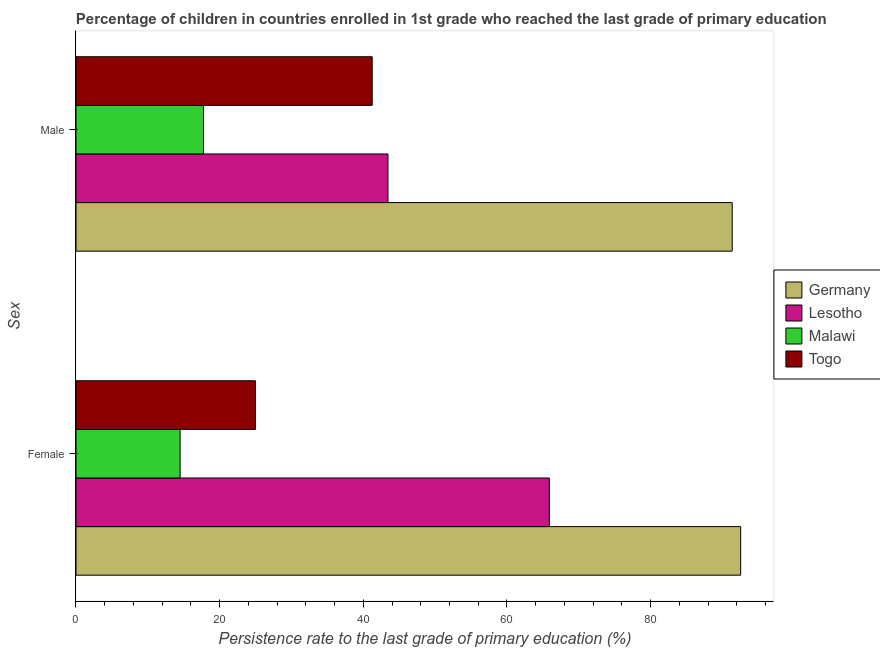How many different coloured bars are there?
Offer a very short reply. 4. How many bars are there on the 2nd tick from the bottom?
Your answer should be compact. 4. What is the persistence rate of male students in Togo?
Your response must be concise. 41.24. Across all countries, what is the maximum persistence rate of male students?
Your answer should be compact. 91.37. Across all countries, what is the minimum persistence rate of female students?
Your answer should be compact. 14.5. In which country was the persistence rate of female students minimum?
Provide a short and direct response. Malawi. What is the total persistence rate of female students in the graph?
Offer a very short reply. 197.93. What is the difference between the persistence rate of male students in Germany and that in Togo?
Keep it short and to the point. 50.13. What is the difference between the persistence rate of female students in Germany and the persistence rate of male students in Togo?
Provide a succinct answer. 51.3. What is the average persistence rate of female students per country?
Your response must be concise. 49.48. What is the difference between the persistence rate of female students and persistence rate of male students in Togo?
Keep it short and to the point. -16.26. What is the ratio of the persistence rate of male students in Malawi to that in Germany?
Ensure brevity in your answer.  0.19. Is the persistence rate of male students in Germany less than that in Lesotho?
Offer a terse response. No. What does the 2nd bar from the top in Female represents?
Your response must be concise. Malawi. Are all the bars in the graph horizontal?
Provide a succinct answer. Yes. What is the difference between two consecutive major ticks on the X-axis?
Ensure brevity in your answer.  20. Are the values on the major ticks of X-axis written in scientific E-notation?
Offer a very short reply. No. Does the graph contain any zero values?
Keep it short and to the point. No. Does the graph contain grids?
Make the answer very short. No. How many legend labels are there?
Make the answer very short. 4. How are the legend labels stacked?
Keep it short and to the point. Vertical. What is the title of the graph?
Your answer should be compact. Percentage of children in countries enrolled in 1st grade who reached the last grade of primary education. What is the label or title of the X-axis?
Offer a terse response. Persistence rate to the last grade of primary education (%). What is the label or title of the Y-axis?
Offer a terse response. Sex. What is the Persistence rate to the last grade of primary education (%) of Germany in Female?
Make the answer very short. 92.54. What is the Persistence rate to the last grade of primary education (%) of Lesotho in Female?
Offer a very short reply. 65.9. What is the Persistence rate to the last grade of primary education (%) of Malawi in Female?
Provide a short and direct response. 14.5. What is the Persistence rate to the last grade of primary education (%) in Togo in Female?
Your response must be concise. 24.99. What is the Persistence rate to the last grade of primary education (%) of Germany in Male?
Your answer should be compact. 91.37. What is the Persistence rate to the last grade of primary education (%) of Lesotho in Male?
Ensure brevity in your answer.  43.44. What is the Persistence rate to the last grade of primary education (%) of Malawi in Male?
Your answer should be compact. 17.75. What is the Persistence rate to the last grade of primary education (%) of Togo in Male?
Ensure brevity in your answer.  41.24. Across all Sex, what is the maximum Persistence rate to the last grade of primary education (%) in Germany?
Your answer should be compact. 92.54. Across all Sex, what is the maximum Persistence rate to the last grade of primary education (%) in Lesotho?
Your answer should be compact. 65.9. Across all Sex, what is the maximum Persistence rate to the last grade of primary education (%) in Malawi?
Your answer should be compact. 17.75. Across all Sex, what is the maximum Persistence rate to the last grade of primary education (%) of Togo?
Offer a terse response. 41.24. Across all Sex, what is the minimum Persistence rate to the last grade of primary education (%) of Germany?
Provide a short and direct response. 91.37. Across all Sex, what is the minimum Persistence rate to the last grade of primary education (%) in Lesotho?
Offer a terse response. 43.44. Across all Sex, what is the minimum Persistence rate to the last grade of primary education (%) in Malawi?
Offer a terse response. 14.5. Across all Sex, what is the minimum Persistence rate to the last grade of primary education (%) in Togo?
Provide a succinct answer. 24.99. What is the total Persistence rate to the last grade of primary education (%) of Germany in the graph?
Your answer should be compact. 183.92. What is the total Persistence rate to the last grade of primary education (%) of Lesotho in the graph?
Your answer should be very brief. 109.34. What is the total Persistence rate to the last grade of primary education (%) in Malawi in the graph?
Offer a terse response. 32.25. What is the total Persistence rate to the last grade of primary education (%) of Togo in the graph?
Provide a succinct answer. 66.23. What is the difference between the Persistence rate to the last grade of primary education (%) of Germany in Female and that in Male?
Keep it short and to the point. 1.17. What is the difference between the Persistence rate to the last grade of primary education (%) of Lesotho in Female and that in Male?
Make the answer very short. 22.47. What is the difference between the Persistence rate to the last grade of primary education (%) of Malawi in Female and that in Male?
Your response must be concise. -3.25. What is the difference between the Persistence rate to the last grade of primary education (%) in Togo in Female and that in Male?
Your answer should be compact. -16.26. What is the difference between the Persistence rate to the last grade of primary education (%) in Germany in Female and the Persistence rate to the last grade of primary education (%) in Lesotho in Male?
Make the answer very short. 49.11. What is the difference between the Persistence rate to the last grade of primary education (%) of Germany in Female and the Persistence rate to the last grade of primary education (%) of Malawi in Male?
Make the answer very short. 74.79. What is the difference between the Persistence rate to the last grade of primary education (%) in Germany in Female and the Persistence rate to the last grade of primary education (%) in Togo in Male?
Make the answer very short. 51.3. What is the difference between the Persistence rate to the last grade of primary education (%) in Lesotho in Female and the Persistence rate to the last grade of primary education (%) in Malawi in Male?
Your response must be concise. 48.15. What is the difference between the Persistence rate to the last grade of primary education (%) of Lesotho in Female and the Persistence rate to the last grade of primary education (%) of Togo in Male?
Your answer should be compact. 24.66. What is the difference between the Persistence rate to the last grade of primary education (%) in Malawi in Female and the Persistence rate to the last grade of primary education (%) in Togo in Male?
Your response must be concise. -26.74. What is the average Persistence rate to the last grade of primary education (%) of Germany per Sex?
Offer a terse response. 91.96. What is the average Persistence rate to the last grade of primary education (%) of Lesotho per Sex?
Your answer should be compact. 54.67. What is the average Persistence rate to the last grade of primary education (%) of Malawi per Sex?
Provide a succinct answer. 16.13. What is the average Persistence rate to the last grade of primary education (%) in Togo per Sex?
Your answer should be very brief. 33.11. What is the difference between the Persistence rate to the last grade of primary education (%) in Germany and Persistence rate to the last grade of primary education (%) in Lesotho in Female?
Make the answer very short. 26.64. What is the difference between the Persistence rate to the last grade of primary education (%) in Germany and Persistence rate to the last grade of primary education (%) in Malawi in Female?
Your answer should be compact. 78.04. What is the difference between the Persistence rate to the last grade of primary education (%) of Germany and Persistence rate to the last grade of primary education (%) of Togo in Female?
Offer a very short reply. 67.56. What is the difference between the Persistence rate to the last grade of primary education (%) in Lesotho and Persistence rate to the last grade of primary education (%) in Malawi in Female?
Provide a short and direct response. 51.4. What is the difference between the Persistence rate to the last grade of primary education (%) of Lesotho and Persistence rate to the last grade of primary education (%) of Togo in Female?
Your answer should be very brief. 40.92. What is the difference between the Persistence rate to the last grade of primary education (%) of Malawi and Persistence rate to the last grade of primary education (%) of Togo in Female?
Offer a terse response. -10.49. What is the difference between the Persistence rate to the last grade of primary education (%) in Germany and Persistence rate to the last grade of primary education (%) in Lesotho in Male?
Offer a very short reply. 47.93. What is the difference between the Persistence rate to the last grade of primary education (%) of Germany and Persistence rate to the last grade of primary education (%) of Malawi in Male?
Offer a very short reply. 73.62. What is the difference between the Persistence rate to the last grade of primary education (%) in Germany and Persistence rate to the last grade of primary education (%) in Togo in Male?
Provide a short and direct response. 50.13. What is the difference between the Persistence rate to the last grade of primary education (%) of Lesotho and Persistence rate to the last grade of primary education (%) of Malawi in Male?
Ensure brevity in your answer.  25.68. What is the difference between the Persistence rate to the last grade of primary education (%) of Lesotho and Persistence rate to the last grade of primary education (%) of Togo in Male?
Offer a terse response. 2.19. What is the difference between the Persistence rate to the last grade of primary education (%) of Malawi and Persistence rate to the last grade of primary education (%) of Togo in Male?
Provide a short and direct response. -23.49. What is the ratio of the Persistence rate to the last grade of primary education (%) of Germany in Female to that in Male?
Offer a very short reply. 1.01. What is the ratio of the Persistence rate to the last grade of primary education (%) of Lesotho in Female to that in Male?
Your answer should be very brief. 1.52. What is the ratio of the Persistence rate to the last grade of primary education (%) of Malawi in Female to that in Male?
Ensure brevity in your answer.  0.82. What is the ratio of the Persistence rate to the last grade of primary education (%) in Togo in Female to that in Male?
Make the answer very short. 0.61. What is the difference between the highest and the second highest Persistence rate to the last grade of primary education (%) in Germany?
Ensure brevity in your answer.  1.17. What is the difference between the highest and the second highest Persistence rate to the last grade of primary education (%) of Lesotho?
Provide a succinct answer. 22.47. What is the difference between the highest and the second highest Persistence rate to the last grade of primary education (%) in Malawi?
Your answer should be compact. 3.25. What is the difference between the highest and the second highest Persistence rate to the last grade of primary education (%) of Togo?
Give a very brief answer. 16.26. What is the difference between the highest and the lowest Persistence rate to the last grade of primary education (%) in Germany?
Offer a terse response. 1.17. What is the difference between the highest and the lowest Persistence rate to the last grade of primary education (%) in Lesotho?
Your answer should be very brief. 22.47. What is the difference between the highest and the lowest Persistence rate to the last grade of primary education (%) in Malawi?
Provide a succinct answer. 3.25. What is the difference between the highest and the lowest Persistence rate to the last grade of primary education (%) in Togo?
Offer a terse response. 16.26. 